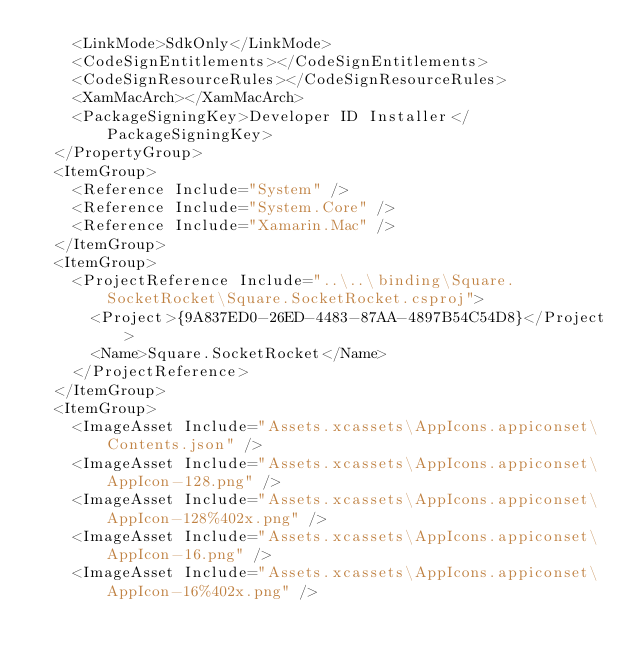<code> <loc_0><loc_0><loc_500><loc_500><_XML_>    <LinkMode>SdkOnly</LinkMode>
    <CodeSignEntitlements></CodeSignEntitlements>
    <CodeSignResourceRules></CodeSignResourceRules>
    <XamMacArch></XamMacArch>
    <PackageSigningKey>Developer ID Installer</PackageSigningKey>
  </PropertyGroup>
  <ItemGroup>
    <Reference Include="System" />
    <Reference Include="System.Core" />
    <Reference Include="Xamarin.Mac" />
  </ItemGroup>
  <ItemGroup>
    <ProjectReference Include="..\..\binding\Square.SocketRocket\Square.SocketRocket.csproj">
      <Project>{9A837ED0-26ED-4483-87AA-4897B54C54D8}</Project>
      <Name>Square.SocketRocket</Name>
    </ProjectReference>
  </ItemGroup>
  <ItemGroup>
    <ImageAsset Include="Assets.xcassets\AppIcons.appiconset\Contents.json" />
    <ImageAsset Include="Assets.xcassets\AppIcons.appiconset\AppIcon-128.png" />
    <ImageAsset Include="Assets.xcassets\AppIcons.appiconset\AppIcon-128%402x.png" />
    <ImageAsset Include="Assets.xcassets\AppIcons.appiconset\AppIcon-16.png" />
    <ImageAsset Include="Assets.xcassets\AppIcons.appiconset\AppIcon-16%402x.png" /></code> 